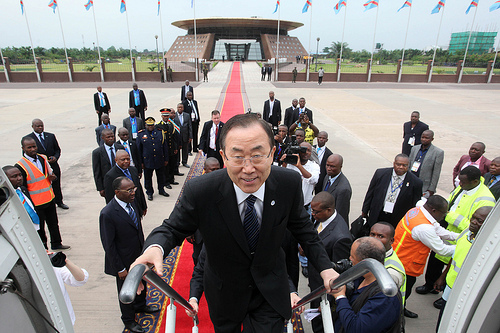<image>
Can you confirm if the guy is in front of the guy? Yes. The guy is positioned in front of the guy, appearing closer to the camera viewpoint. 